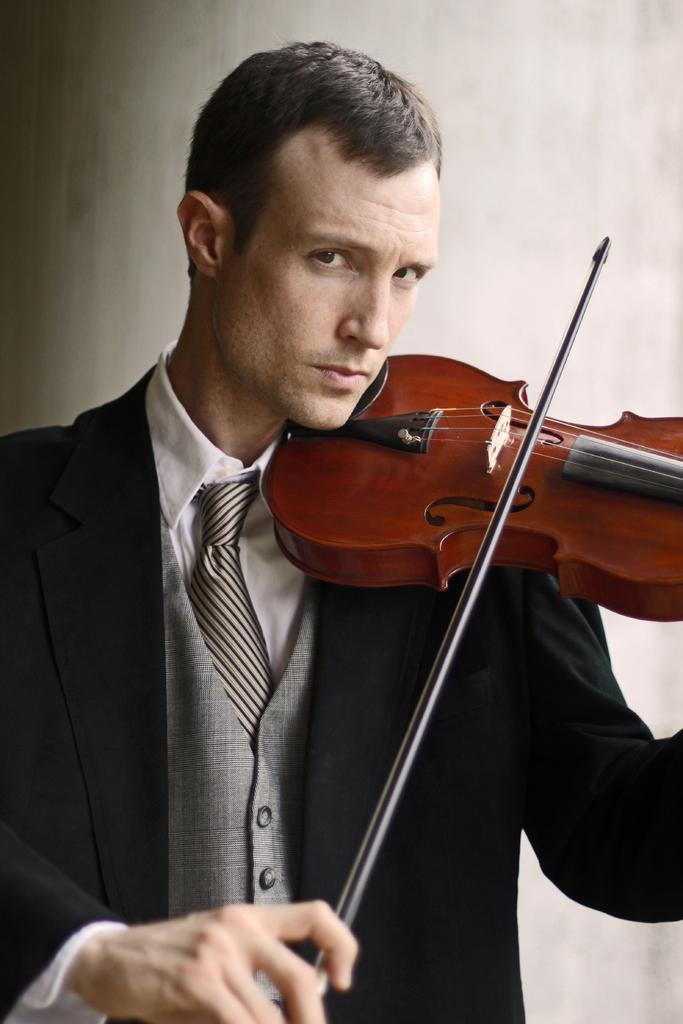What is the main subject of the image? The main subject of the image is a man. What is the man doing in the image? The man is standing and playing the violin. What object is the man holding in his hand? The man is holding a violin in his hand. What type of bead is the man wearing around his neck in the image? There is no bead visible around the man's neck in the image. How does the sky look like in the image? The provided facts do not mention anything about the sky, so we cannot determine its appearance from the image. 